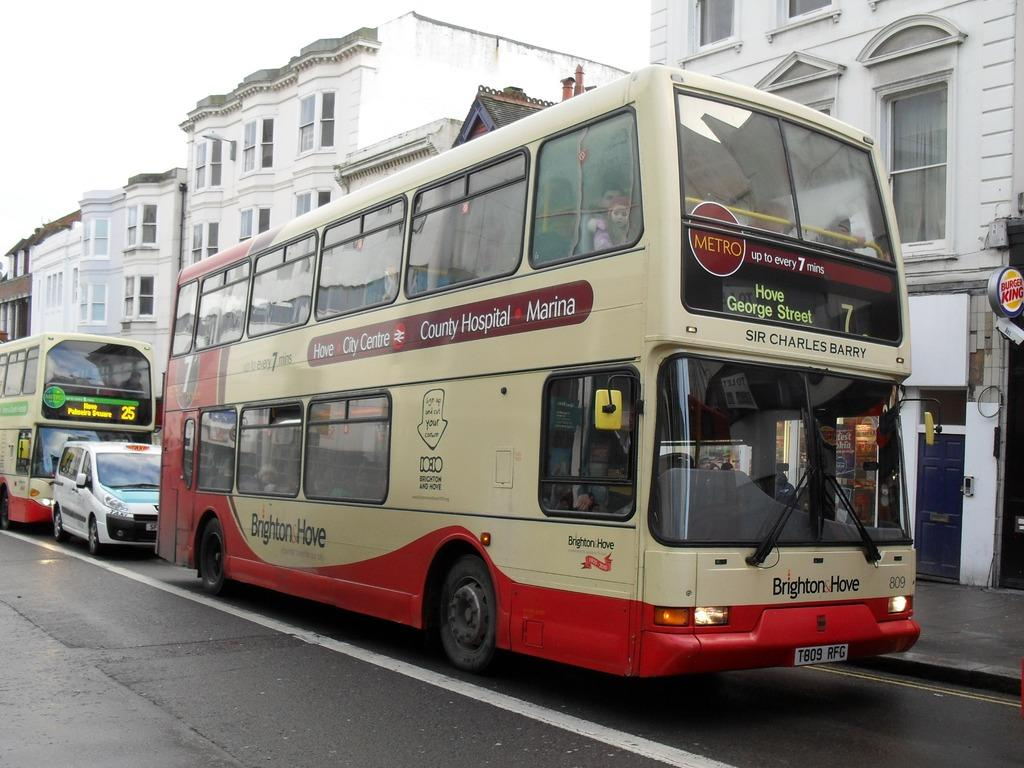Provide a one-sentence caption for the provided image. A double decker bus from Brighton and Hove is running the number 7 route. 